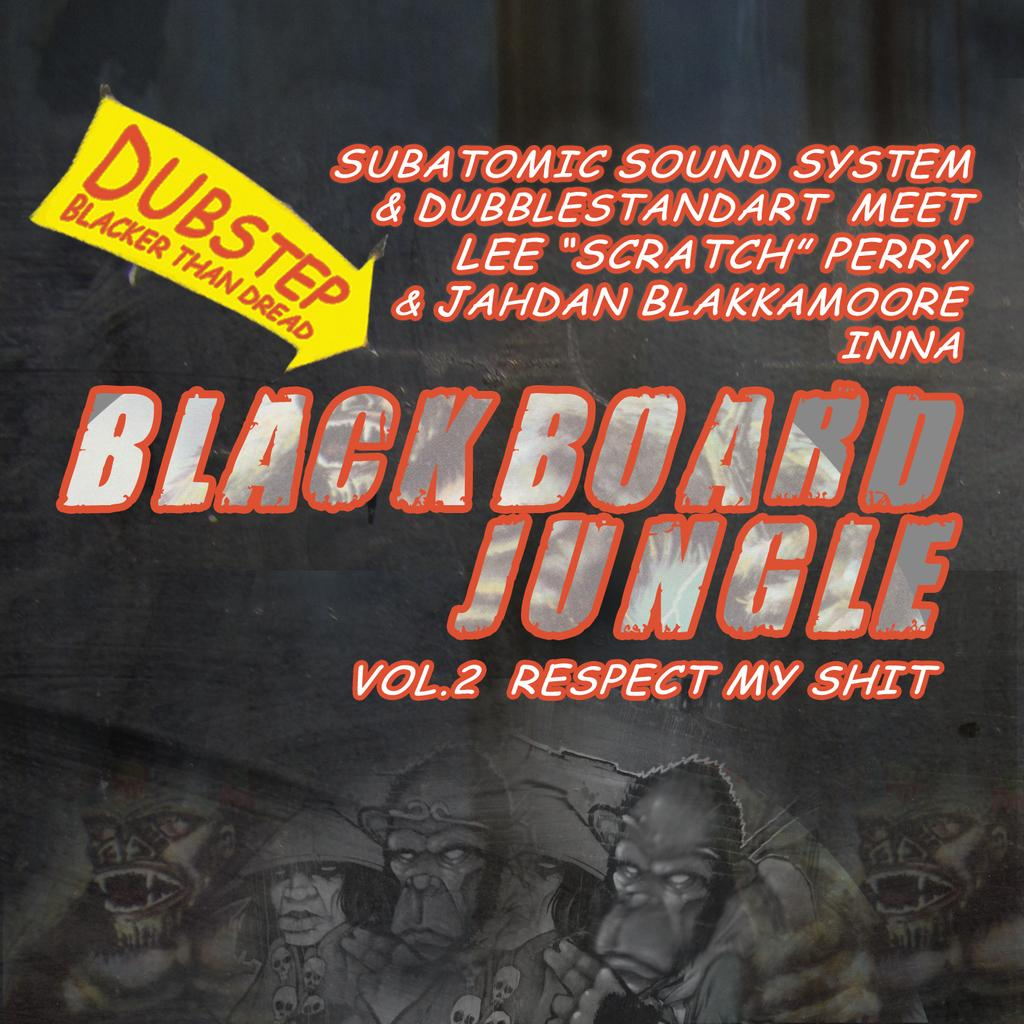What is present on the poster in the image? There is a poster in the image, and it contains the word "alliance." Can you describe any other features of the poster? Yes, there is text on the poster. What letter is being used to write the word "alliance" on the poster? There is no information about the specific letter being used to write the word "alliance" on the poster. 